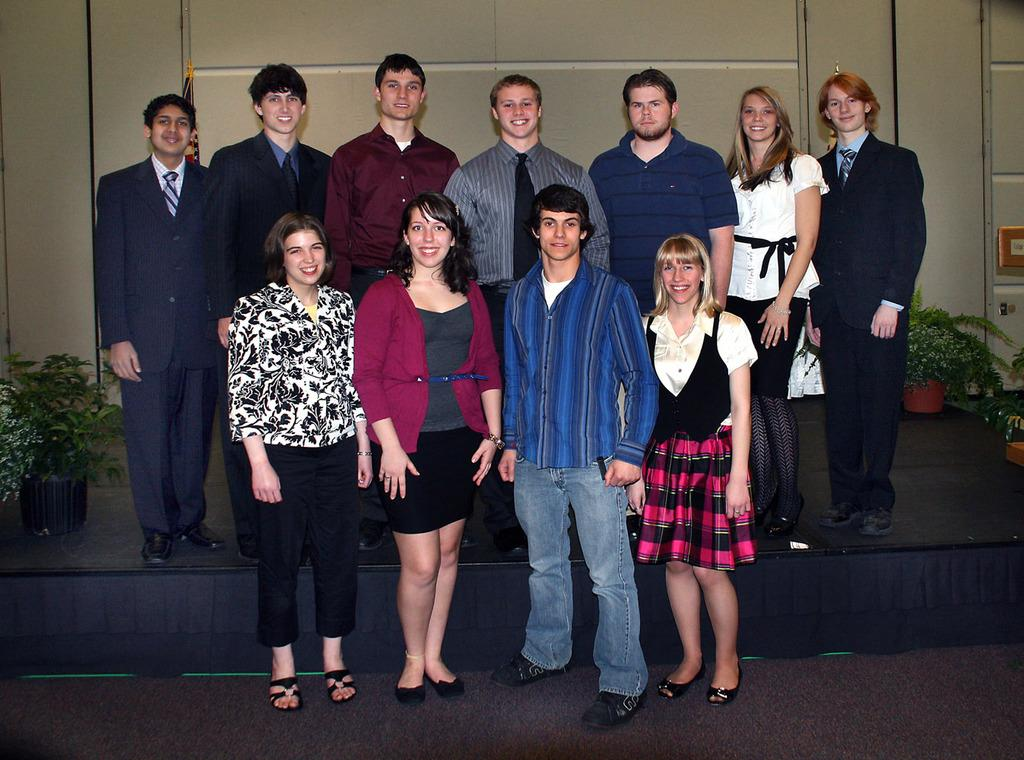What is happening in the foreground of the image? There is a group of people standing in the foreground of the image. What can be seen on either side of the group? There are plants on either side of the group. What is visible in the background of the image? There is a wall in the background of the image. What type of apple is being used for educational purposes in the image? There is no apple or educational activity present in the image. 